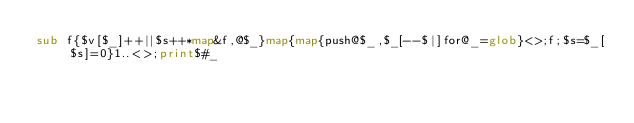<code> <loc_0><loc_0><loc_500><loc_500><_Perl_>sub f{$v[$_]++||$s++*map&f,@$_}map{map{push@$_,$_[--$|]for@_=glob}<>;f;$s=$_[$s]=0}1..<>;print$#_
</code> 